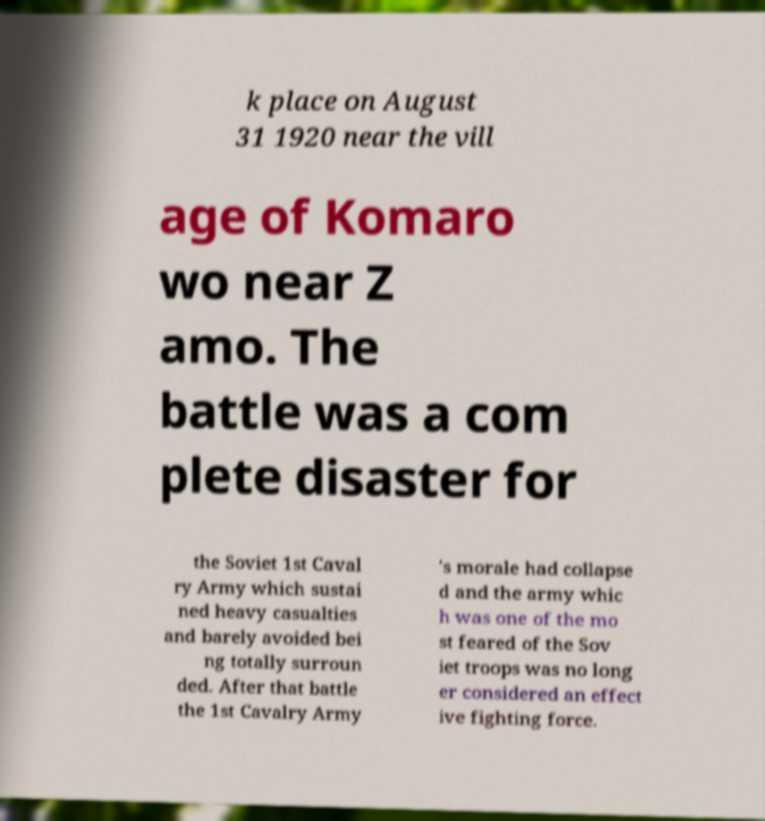Please identify and transcribe the text found in this image. k place on August 31 1920 near the vill age of Komaro wo near Z amo. The battle was a com plete disaster for the Soviet 1st Caval ry Army which sustai ned heavy casualties and barely avoided bei ng totally surroun ded. After that battle the 1st Cavalry Army 's morale had collapse d and the army whic h was one of the mo st feared of the Sov iet troops was no long er considered an effect ive fighting force. 